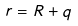<formula> <loc_0><loc_0><loc_500><loc_500>r = R + q</formula> 